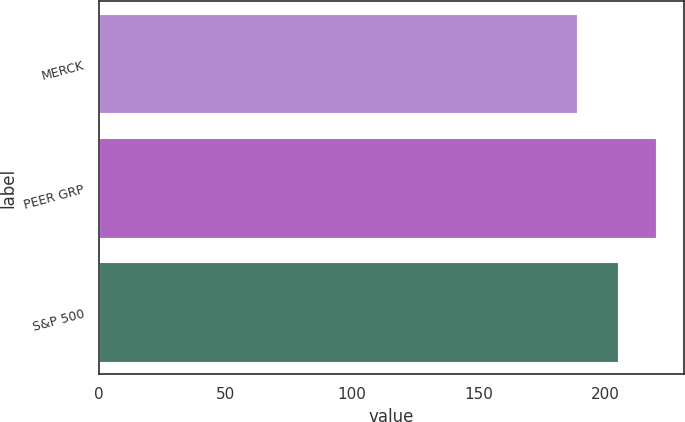<chart> <loc_0><loc_0><loc_500><loc_500><bar_chart><fcel>MERCK<fcel>PEER GRP<fcel>S&P 500<nl><fcel>189.02<fcel>220.29<fcel>205<nl></chart> 